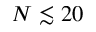Convert formula to latex. <formula><loc_0><loc_0><loc_500><loc_500>N \lesssim 2 0</formula> 